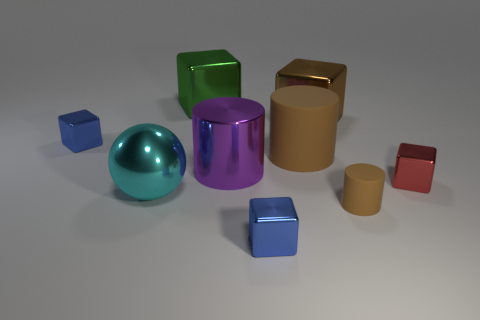How many objects have a cylindrical shape? There are two objects with a cylindrical shape. One is large and brown, while the other is smaller and of a cream color. 